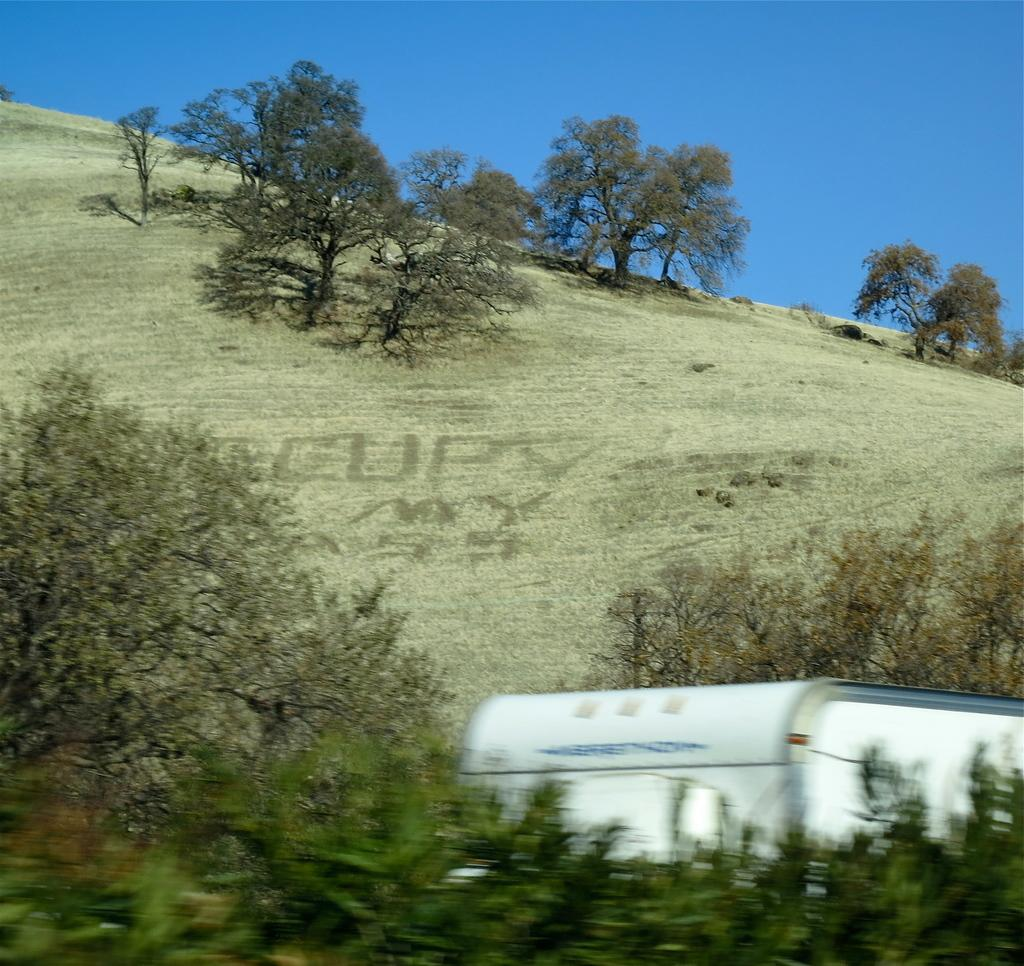What type of natural elements can be seen in the image? There are trees in the image. What man-made object is present in the image? There is a vehicle in the image. What geographical features are visible in the image? There are hills in the image. What is visible at the top of the image? The sky is visible at the top of the image. What type of mine can be seen in the image? There is no mine present in the image. What scientific theory is being demonstrated in the image? The image does not depict a scientific theory. 